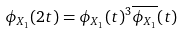Convert formula to latex. <formula><loc_0><loc_0><loc_500><loc_500>\phi _ { X _ { 1 } } ( 2 t ) = \phi _ { X _ { 1 } } ( t ) ^ { 3 } \overline { \phi _ { X _ { 1 } } } ( t )</formula> 